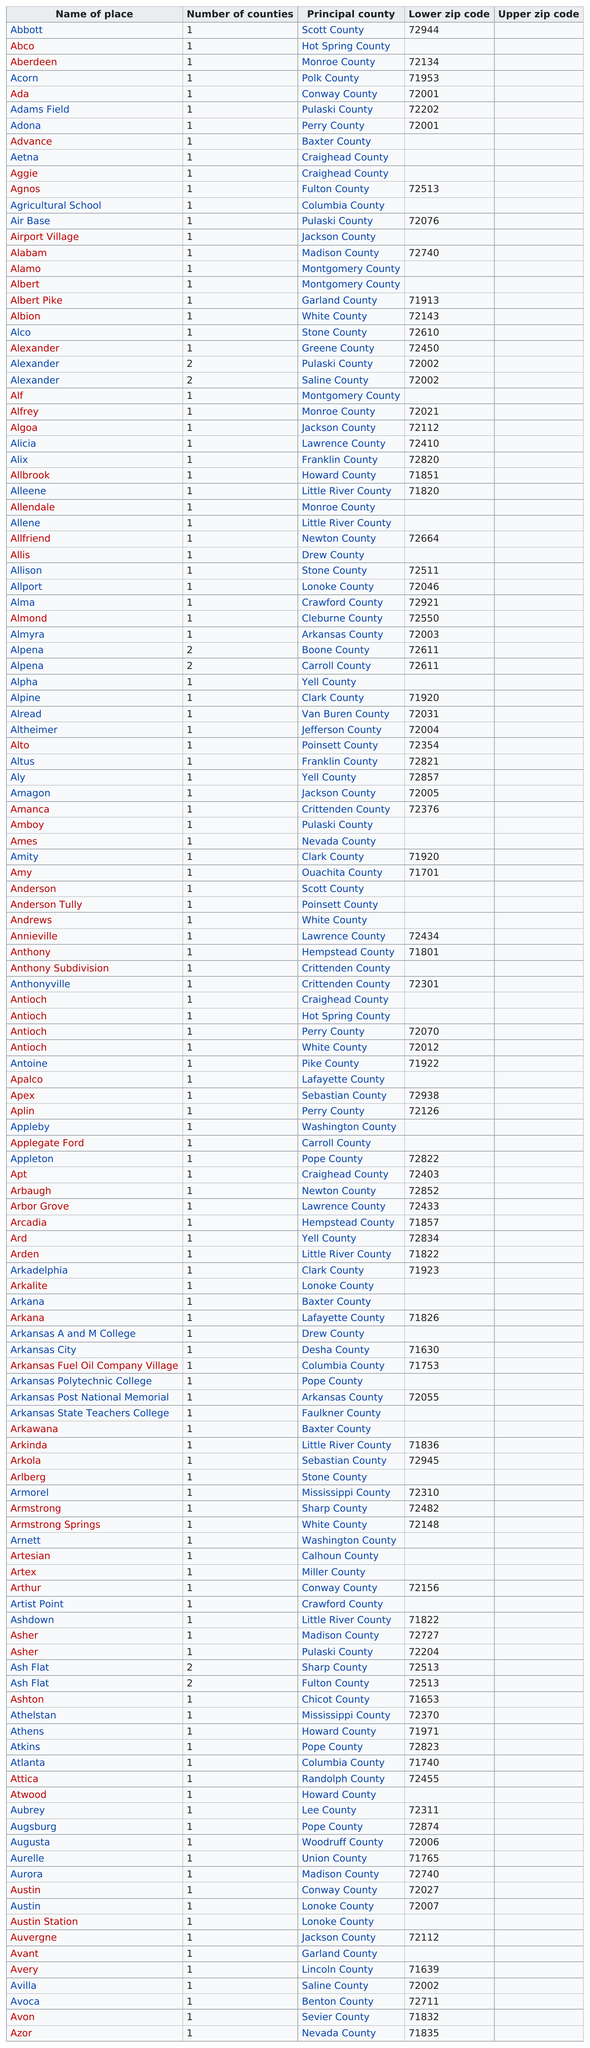Highlight a few significant elements in this photo. There are three places that are called Alexander. After finding the zip code 72610, the next place on the list is Alexander. There are 38 places that do not have a lower ZIP code. Six places have more than one county. The city that is the last alphabetically listed is Azor. 